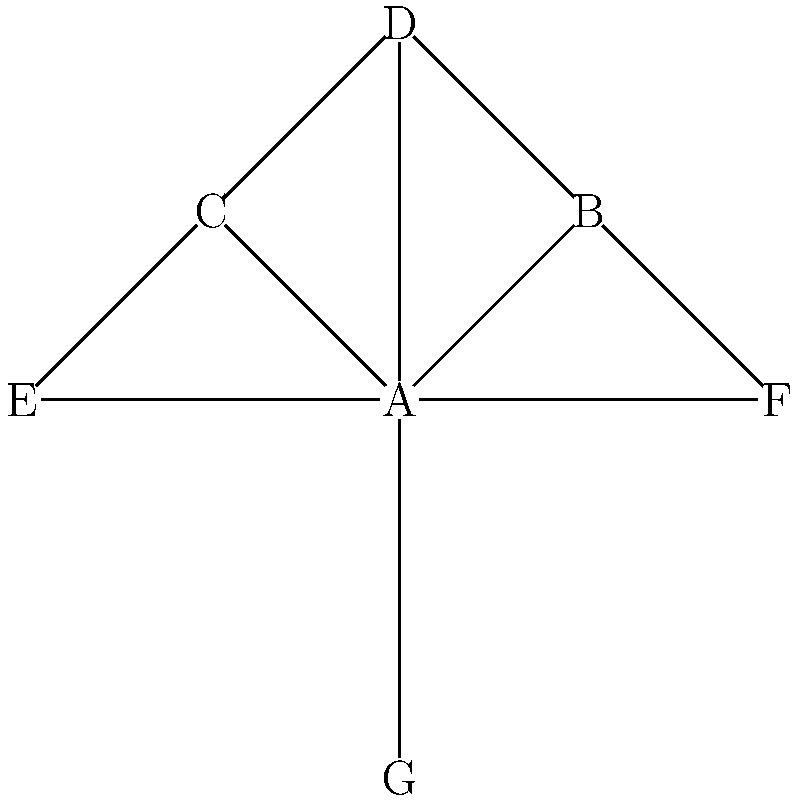In the given professional network diagram, which individual is best positioned to control information flow and influence others? Justify your answer based on network centrality and connectivity. To determine the individual best positioned to control information flow and influence others, we need to analyze the network structure:

1. Degree Centrality: Count the number of direct connections each node has.
   A: 6, B: 2, C: 3, D: 3, E: 2, F: 2, G: 1

2. Betweenness Centrality: Identify nodes that act as bridges between other nodes.
   Node A is on the shortest path between almost all pairs of nodes.

3. Closeness Centrality: Measure how close a node is to all other nodes.
   Node A has the shortest average path length to all other nodes.

4. Network Position:
   - A is at the center of the network, connected to all other nodes.
   - A can reach any other node in one step, while others require at least two steps.

5. Information Control:
   - A can directly communicate with all other nodes.
   - A can potentially filter or manipulate information passing between other nodes.

6. Influence Potential:
   - A's central position allows for quick dissemination of information.
   - A can potentially isolate nodes by controlling their only connection to the network.

Based on these factors, node A has the highest centrality measures and is in the best position to control information flow and influence others in the network.
Answer: Node A 